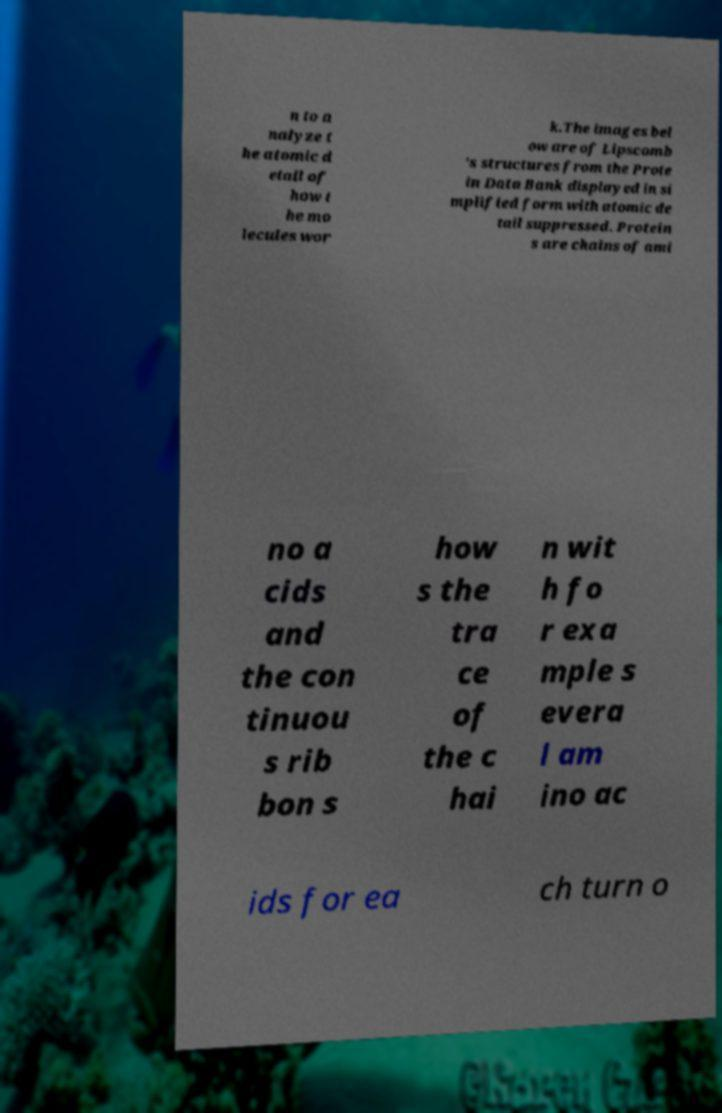What messages or text are displayed in this image? I need them in a readable, typed format. n to a nalyze t he atomic d etail of how t he mo lecules wor k.The images bel ow are of Lipscomb 's structures from the Prote in Data Bank displayed in si mplified form with atomic de tail suppressed. Protein s are chains of ami no a cids and the con tinuou s rib bon s how s the tra ce of the c hai n wit h fo r exa mple s evera l am ino ac ids for ea ch turn o 